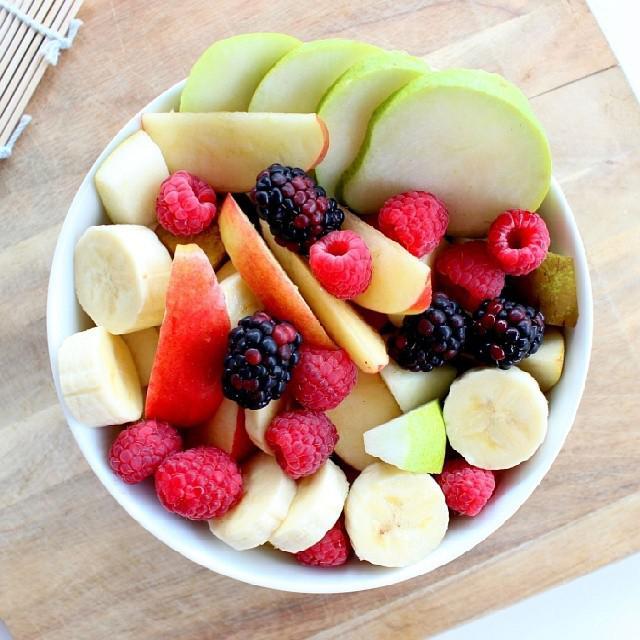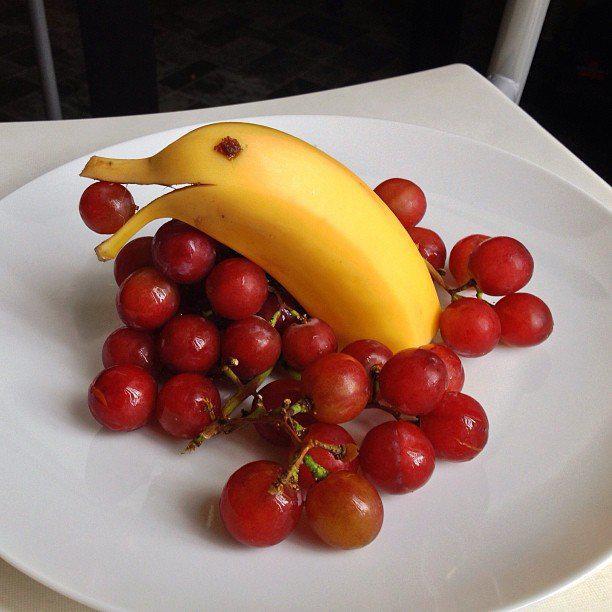The first image is the image on the left, the second image is the image on the right. Examine the images to the left and right. Is the description "Some of the fruit is clearly in a bowl." accurate? Answer yes or no. Yes. The first image is the image on the left, the second image is the image on the right. Given the left and right images, does the statement "A banana with its peel on is next to a bunch of reddish grapes in the right image." hold true? Answer yes or no. Yes. 